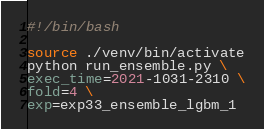Convert code to text. <code><loc_0><loc_0><loc_500><loc_500><_Bash_>#!/bin/bash

source ./venv/bin/activate
python run_ensemble.py \
exec_time=2021-1031-2310 \
fold=4 \
exp=exp33_ensemble_lgbm_1</code> 